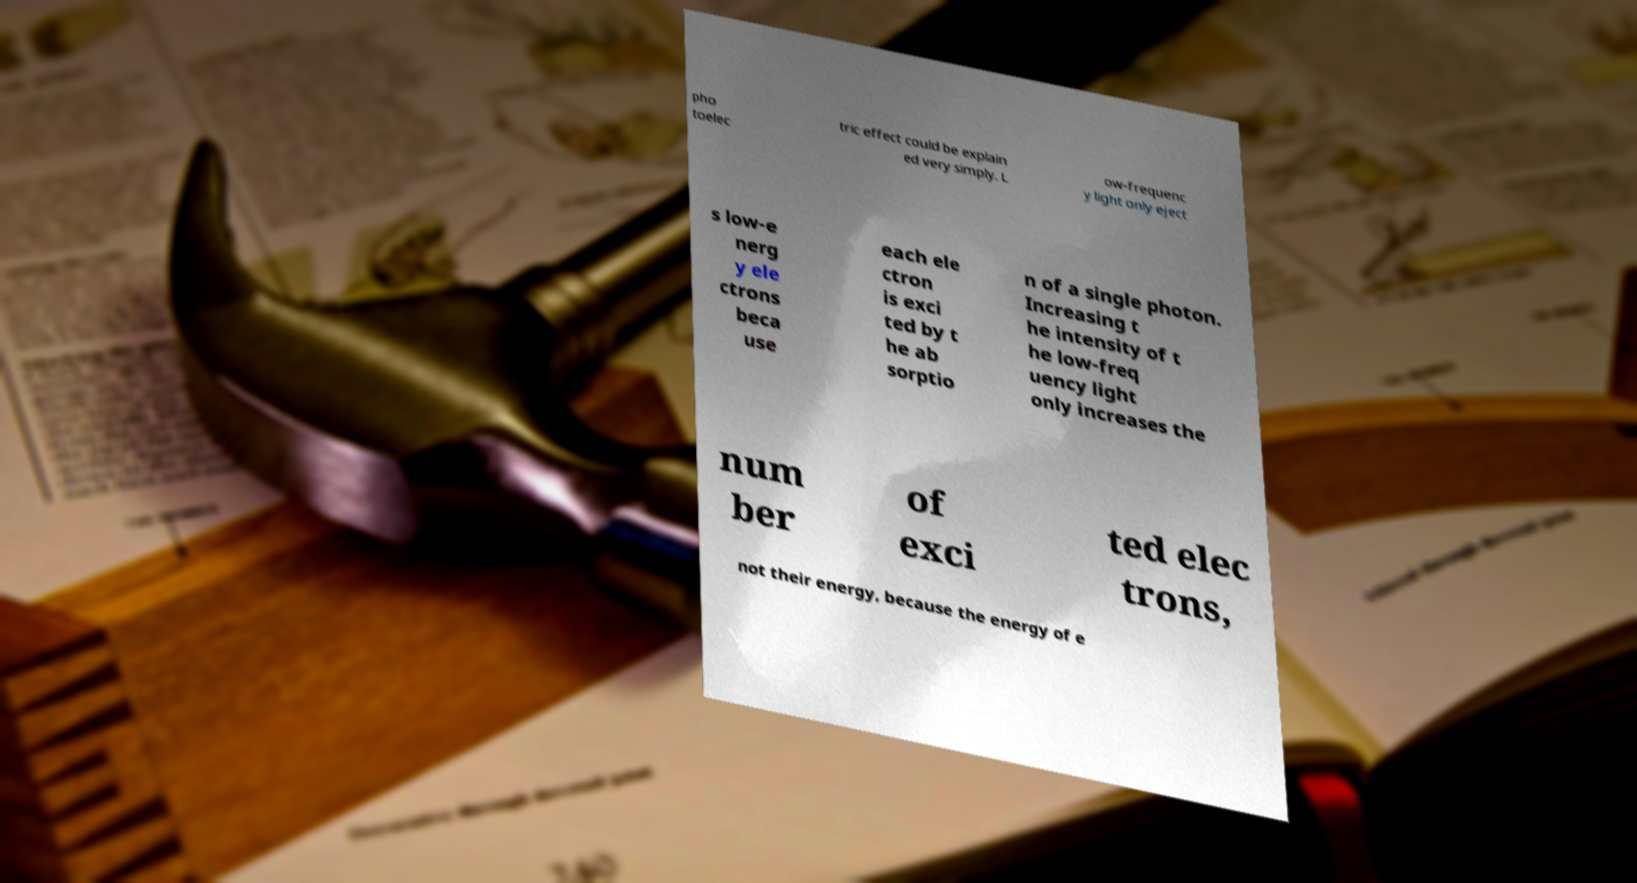I need the written content from this picture converted into text. Can you do that? pho toelec tric effect could be explain ed very simply. L ow-frequenc y light only eject s low-e nerg y ele ctrons beca use each ele ctron is exci ted by t he ab sorptio n of a single photon. Increasing t he intensity of t he low-freq uency light only increases the num ber of exci ted elec trons, not their energy, because the energy of e 